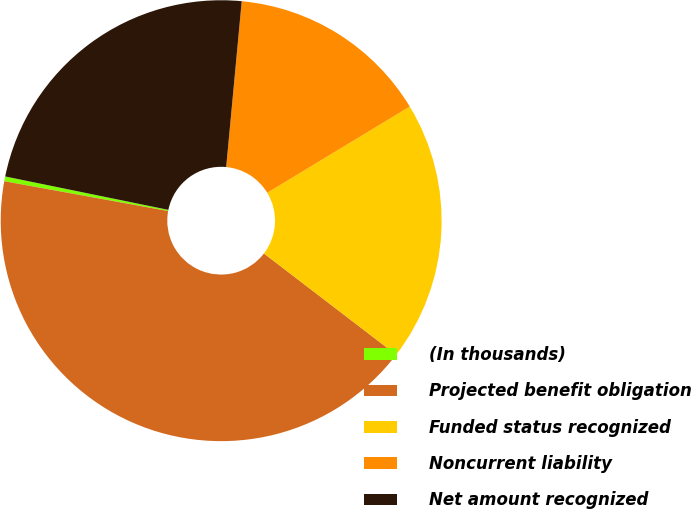<chart> <loc_0><loc_0><loc_500><loc_500><pie_chart><fcel>(In thousands)<fcel>Projected benefit obligation<fcel>Funded status recognized<fcel>Noncurrent liability<fcel>Net amount recognized<nl><fcel>0.35%<fcel>42.46%<fcel>19.06%<fcel>14.85%<fcel>23.27%<nl></chart> 